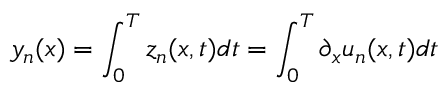<formula> <loc_0><loc_0><loc_500><loc_500>y _ { n } ( x ) = \int _ { 0 } ^ { T } z _ { n } ( x , t ) d t = \int _ { 0 } ^ { T } \partial _ { x } u _ { n } ( x , t ) d t</formula> 